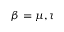Convert formula to latex. <formula><loc_0><loc_0><loc_500><loc_500>\beta = \mu , \tau</formula> 